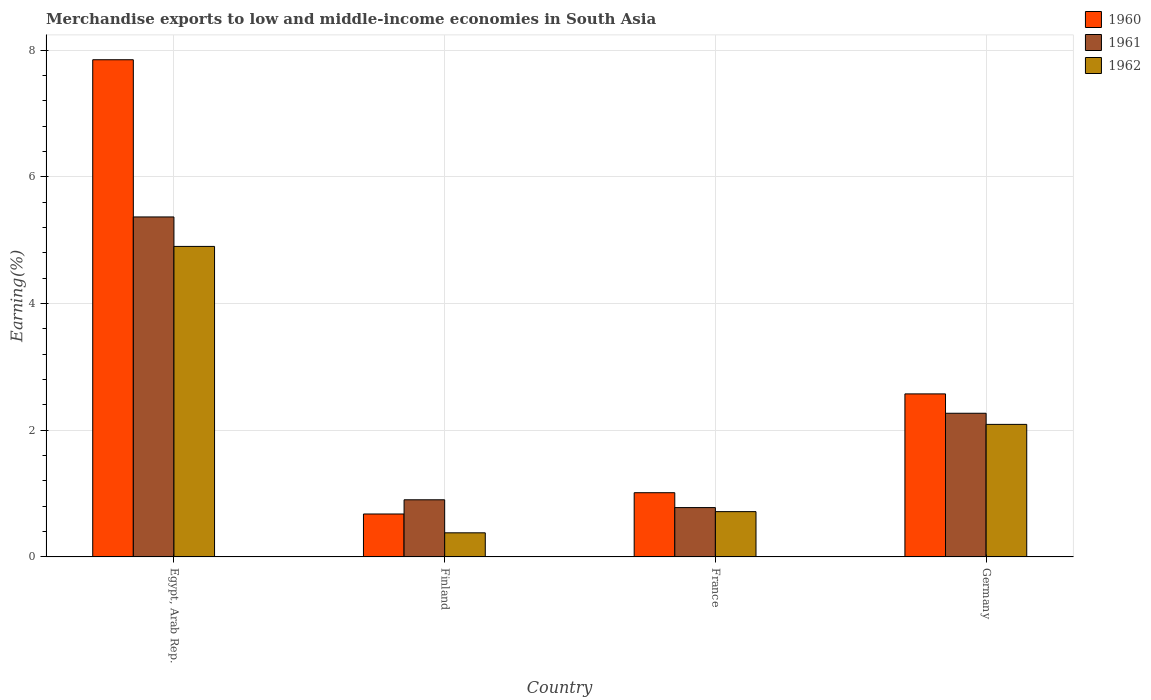How many groups of bars are there?
Give a very brief answer. 4. Are the number of bars per tick equal to the number of legend labels?
Your answer should be compact. Yes. Are the number of bars on each tick of the X-axis equal?
Keep it short and to the point. Yes. How many bars are there on the 2nd tick from the left?
Make the answer very short. 3. How many bars are there on the 3rd tick from the right?
Offer a terse response. 3. What is the percentage of amount earned from merchandise exports in 1960 in Finland?
Ensure brevity in your answer.  0.68. Across all countries, what is the maximum percentage of amount earned from merchandise exports in 1962?
Offer a terse response. 4.9. Across all countries, what is the minimum percentage of amount earned from merchandise exports in 1962?
Your answer should be very brief. 0.38. In which country was the percentage of amount earned from merchandise exports in 1962 maximum?
Your answer should be very brief. Egypt, Arab Rep. What is the total percentage of amount earned from merchandise exports in 1961 in the graph?
Your answer should be very brief. 9.32. What is the difference between the percentage of amount earned from merchandise exports in 1962 in Egypt, Arab Rep. and that in Finland?
Provide a short and direct response. 4.52. What is the difference between the percentage of amount earned from merchandise exports in 1960 in Finland and the percentage of amount earned from merchandise exports in 1961 in Germany?
Give a very brief answer. -1.59. What is the average percentage of amount earned from merchandise exports in 1961 per country?
Your response must be concise. 2.33. What is the difference between the percentage of amount earned from merchandise exports of/in 1961 and percentage of amount earned from merchandise exports of/in 1960 in Finland?
Make the answer very short. 0.22. In how many countries, is the percentage of amount earned from merchandise exports in 1961 greater than 2.4 %?
Offer a terse response. 1. What is the ratio of the percentage of amount earned from merchandise exports in 1962 in Finland to that in France?
Make the answer very short. 0.53. What is the difference between the highest and the second highest percentage of amount earned from merchandise exports in 1960?
Your answer should be very brief. -1.56. What is the difference between the highest and the lowest percentage of amount earned from merchandise exports in 1961?
Make the answer very short. 4.59. What does the 3rd bar from the left in Germany represents?
Give a very brief answer. 1962. What does the 2nd bar from the right in Egypt, Arab Rep. represents?
Offer a terse response. 1961. Is it the case that in every country, the sum of the percentage of amount earned from merchandise exports in 1960 and percentage of amount earned from merchandise exports in 1962 is greater than the percentage of amount earned from merchandise exports in 1961?
Provide a short and direct response. Yes. Are the values on the major ticks of Y-axis written in scientific E-notation?
Provide a succinct answer. No. Does the graph contain grids?
Your answer should be compact. Yes. What is the title of the graph?
Make the answer very short. Merchandise exports to low and middle-income economies in South Asia. What is the label or title of the X-axis?
Offer a terse response. Country. What is the label or title of the Y-axis?
Your answer should be very brief. Earning(%). What is the Earning(%) in 1960 in Egypt, Arab Rep.?
Your answer should be compact. 7.85. What is the Earning(%) of 1961 in Egypt, Arab Rep.?
Give a very brief answer. 5.37. What is the Earning(%) of 1962 in Egypt, Arab Rep.?
Your answer should be very brief. 4.9. What is the Earning(%) of 1960 in Finland?
Keep it short and to the point. 0.68. What is the Earning(%) of 1961 in Finland?
Your answer should be compact. 0.9. What is the Earning(%) in 1962 in Finland?
Offer a terse response. 0.38. What is the Earning(%) of 1960 in France?
Give a very brief answer. 1.01. What is the Earning(%) in 1961 in France?
Give a very brief answer. 0.78. What is the Earning(%) in 1962 in France?
Your answer should be very brief. 0.72. What is the Earning(%) of 1960 in Germany?
Your answer should be compact. 2.57. What is the Earning(%) of 1961 in Germany?
Offer a very short reply. 2.27. What is the Earning(%) in 1962 in Germany?
Make the answer very short. 2.09. Across all countries, what is the maximum Earning(%) of 1960?
Give a very brief answer. 7.85. Across all countries, what is the maximum Earning(%) in 1961?
Your response must be concise. 5.37. Across all countries, what is the maximum Earning(%) in 1962?
Ensure brevity in your answer.  4.9. Across all countries, what is the minimum Earning(%) of 1960?
Your answer should be compact. 0.68. Across all countries, what is the minimum Earning(%) in 1961?
Keep it short and to the point. 0.78. Across all countries, what is the minimum Earning(%) of 1962?
Offer a terse response. 0.38. What is the total Earning(%) in 1960 in the graph?
Provide a succinct answer. 12.12. What is the total Earning(%) of 1961 in the graph?
Keep it short and to the point. 9.32. What is the total Earning(%) in 1962 in the graph?
Ensure brevity in your answer.  8.09. What is the difference between the Earning(%) in 1960 in Egypt, Arab Rep. and that in Finland?
Your answer should be compact. 7.17. What is the difference between the Earning(%) in 1961 in Egypt, Arab Rep. and that in Finland?
Make the answer very short. 4.47. What is the difference between the Earning(%) of 1962 in Egypt, Arab Rep. and that in Finland?
Make the answer very short. 4.52. What is the difference between the Earning(%) of 1960 in Egypt, Arab Rep. and that in France?
Keep it short and to the point. 6.84. What is the difference between the Earning(%) in 1961 in Egypt, Arab Rep. and that in France?
Provide a succinct answer. 4.59. What is the difference between the Earning(%) of 1962 in Egypt, Arab Rep. and that in France?
Your answer should be very brief. 4.19. What is the difference between the Earning(%) of 1960 in Egypt, Arab Rep. and that in Germany?
Make the answer very short. 5.28. What is the difference between the Earning(%) of 1961 in Egypt, Arab Rep. and that in Germany?
Provide a succinct answer. 3.1. What is the difference between the Earning(%) of 1962 in Egypt, Arab Rep. and that in Germany?
Offer a terse response. 2.81. What is the difference between the Earning(%) of 1960 in Finland and that in France?
Provide a succinct answer. -0.34. What is the difference between the Earning(%) in 1961 in Finland and that in France?
Offer a very short reply. 0.12. What is the difference between the Earning(%) of 1962 in Finland and that in France?
Your answer should be compact. -0.33. What is the difference between the Earning(%) of 1960 in Finland and that in Germany?
Your answer should be very brief. -1.9. What is the difference between the Earning(%) in 1961 in Finland and that in Germany?
Offer a very short reply. -1.37. What is the difference between the Earning(%) in 1962 in Finland and that in Germany?
Ensure brevity in your answer.  -1.71. What is the difference between the Earning(%) in 1960 in France and that in Germany?
Provide a succinct answer. -1.56. What is the difference between the Earning(%) of 1961 in France and that in Germany?
Keep it short and to the point. -1.49. What is the difference between the Earning(%) in 1962 in France and that in Germany?
Provide a short and direct response. -1.38. What is the difference between the Earning(%) in 1960 in Egypt, Arab Rep. and the Earning(%) in 1961 in Finland?
Your response must be concise. 6.95. What is the difference between the Earning(%) of 1960 in Egypt, Arab Rep. and the Earning(%) of 1962 in Finland?
Make the answer very short. 7.47. What is the difference between the Earning(%) in 1961 in Egypt, Arab Rep. and the Earning(%) in 1962 in Finland?
Ensure brevity in your answer.  4.99. What is the difference between the Earning(%) of 1960 in Egypt, Arab Rep. and the Earning(%) of 1961 in France?
Make the answer very short. 7.07. What is the difference between the Earning(%) in 1960 in Egypt, Arab Rep. and the Earning(%) in 1962 in France?
Give a very brief answer. 7.14. What is the difference between the Earning(%) of 1961 in Egypt, Arab Rep. and the Earning(%) of 1962 in France?
Your response must be concise. 4.65. What is the difference between the Earning(%) in 1960 in Egypt, Arab Rep. and the Earning(%) in 1961 in Germany?
Your response must be concise. 5.58. What is the difference between the Earning(%) of 1960 in Egypt, Arab Rep. and the Earning(%) of 1962 in Germany?
Give a very brief answer. 5.76. What is the difference between the Earning(%) in 1961 in Egypt, Arab Rep. and the Earning(%) in 1962 in Germany?
Your response must be concise. 3.28. What is the difference between the Earning(%) of 1960 in Finland and the Earning(%) of 1961 in France?
Your answer should be very brief. -0.1. What is the difference between the Earning(%) in 1960 in Finland and the Earning(%) in 1962 in France?
Provide a short and direct response. -0.04. What is the difference between the Earning(%) in 1961 in Finland and the Earning(%) in 1962 in France?
Provide a succinct answer. 0.19. What is the difference between the Earning(%) in 1960 in Finland and the Earning(%) in 1961 in Germany?
Keep it short and to the point. -1.59. What is the difference between the Earning(%) of 1960 in Finland and the Earning(%) of 1962 in Germany?
Your answer should be very brief. -1.41. What is the difference between the Earning(%) in 1961 in Finland and the Earning(%) in 1962 in Germany?
Your answer should be very brief. -1.19. What is the difference between the Earning(%) of 1960 in France and the Earning(%) of 1961 in Germany?
Your answer should be very brief. -1.25. What is the difference between the Earning(%) in 1960 in France and the Earning(%) in 1962 in Germany?
Your response must be concise. -1.08. What is the difference between the Earning(%) of 1961 in France and the Earning(%) of 1962 in Germany?
Ensure brevity in your answer.  -1.31. What is the average Earning(%) of 1960 per country?
Provide a succinct answer. 3.03. What is the average Earning(%) in 1961 per country?
Ensure brevity in your answer.  2.33. What is the average Earning(%) of 1962 per country?
Your answer should be very brief. 2.02. What is the difference between the Earning(%) of 1960 and Earning(%) of 1961 in Egypt, Arab Rep.?
Make the answer very short. 2.48. What is the difference between the Earning(%) of 1960 and Earning(%) of 1962 in Egypt, Arab Rep.?
Your answer should be very brief. 2.95. What is the difference between the Earning(%) of 1961 and Earning(%) of 1962 in Egypt, Arab Rep.?
Give a very brief answer. 0.47. What is the difference between the Earning(%) in 1960 and Earning(%) in 1961 in Finland?
Keep it short and to the point. -0.22. What is the difference between the Earning(%) of 1960 and Earning(%) of 1962 in Finland?
Your answer should be very brief. 0.3. What is the difference between the Earning(%) of 1961 and Earning(%) of 1962 in Finland?
Provide a short and direct response. 0.52. What is the difference between the Earning(%) of 1960 and Earning(%) of 1961 in France?
Offer a terse response. 0.23. What is the difference between the Earning(%) of 1960 and Earning(%) of 1962 in France?
Provide a succinct answer. 0.3. What is the difference between the Earning(%) in 1961 and Earning(%) in 1962 in France?
Provide a succinct answer. 0.06. What is the difference between the Earning(%) in 1960 and Earning(%) in 1961 in Germany?
Provide a succinct answer. 0.31. What is the difference between the Earning(%) in 1960 and Earning(%) in 1962 in Germany?
Give a very brief answer. 0.48. What is the difference between the Earning(%) of 1961 and Earning(%) of 1962 in Germany?
Offer a terse response. 0.18. What is the ratio of the Earning(%) of 1960 in Egypt, Arab Rep. to that in Finland?
Your answer should be very brief. 11.58. What is the ratio of the Earning(%) of 1961 in Egypt, Arab Rep. to that in Finland?
Your response must be concise. 5.95. What is the ratio of the Earning(%) in 1962 in Egypt, Arab Rep. to that in Finland?
Keep it short and to the point. 12.88. What is the ratio of the Earning(%) in 1960 in Egypt, Arab Rep. to that in France?
Offer a very short reply. 7.74. What is the ratio of the Earning(%) of 1961 in Egypt, Arab Rep. to that in France?
Give a very brief answer. 6.89. What is the ratio of the Earning(%) of 1962 in Egypt, Arab Rep. to that in France?
Your answer should be compact. 6.85. What is the ratio of the Earning(%) of 1960 in Egypt, Arab Rep. to that in Germany?
Keep it short and to the point. 3.05. What is the ratio of the Earning(%) in 1961 in Egypt, Arab Rep. to that in Germany?
Your response must be concise. 2.37. What is the ratio of the Earning(%) of 1962 in Egypt, Arab Rep. to that in Germany?
Provide a succinct answer. 2.34. What is the ratio of the Earning(%) in 1960 in Finland to that in France?
Your answer should be very brief. 0.67. What is the ratio of the Earning(%) in 1961 in Finland to that in France?
Offer a terse response. 1.16. What is the ratio of the Earning(%) in 1962 in Finland to that in France?
Make the answer very short. 0.53. What is the ratio of the Earning(%) in 1960 in Finland to that in Germany?
Offer a terse response. 0.26. What is the ratio of the Earning(%) in 1961 in Finland to that in Germany?
Make the answer very short. 0.4. What is the ratio of the Earning(%) of 1962 in Finland to that in Germany?
Offer a very short reply. 0.18. What is the ratio of the Earning(%) in 1960 in France to that in Germany?
Your answer should be compact. 0.39. What is the ratio of the Earning(%) of 1961 in France to that in Germany?
Offer a terse response. 0.34. What is the ratio of the Earning(%) in 1962 in France to that in Germany?
Offer a very short reply. 0.34. What is the difference between the highest and the second highest Earning(%) in 1960?
Ensure brevity in your answer.  5.28. What is the difference between the highest and the second highest Earning(%) in 1961?
Make the answer very short. 3.1. What is the difference between the highest and the second highest Earning(%) in 1962?
Offer a very short reply. 2.81. What is the difference between the highest and the lowest Earning(%) of 1960?
Offer a terse response. 7.17. What is the difference between the highest and the lowest Earning(%) in 1961?
Your answer should be compact. 4.59. What is the difference between the highest and the lowest Earning(%) of 1962?
Your response must be concise. 4.52. 